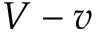<formula> <loc_0><loc_0><loc_500><loc_500>V - v</formula> 